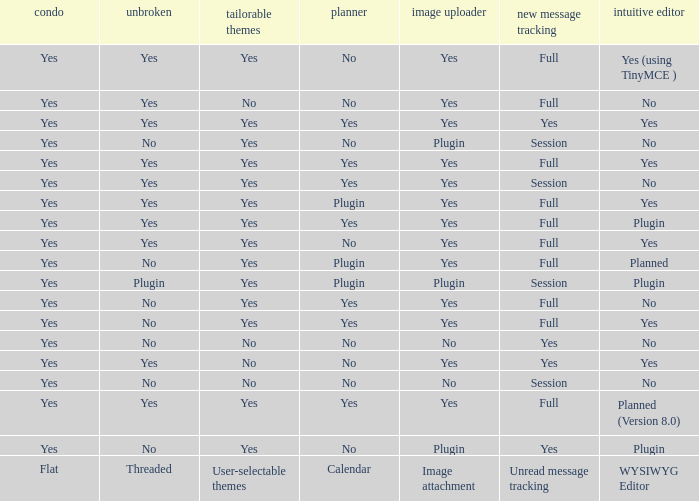Which WYSIWYG Editor has an Image attachment of yes, and a Calendar of plugin? Yes, Planned. 